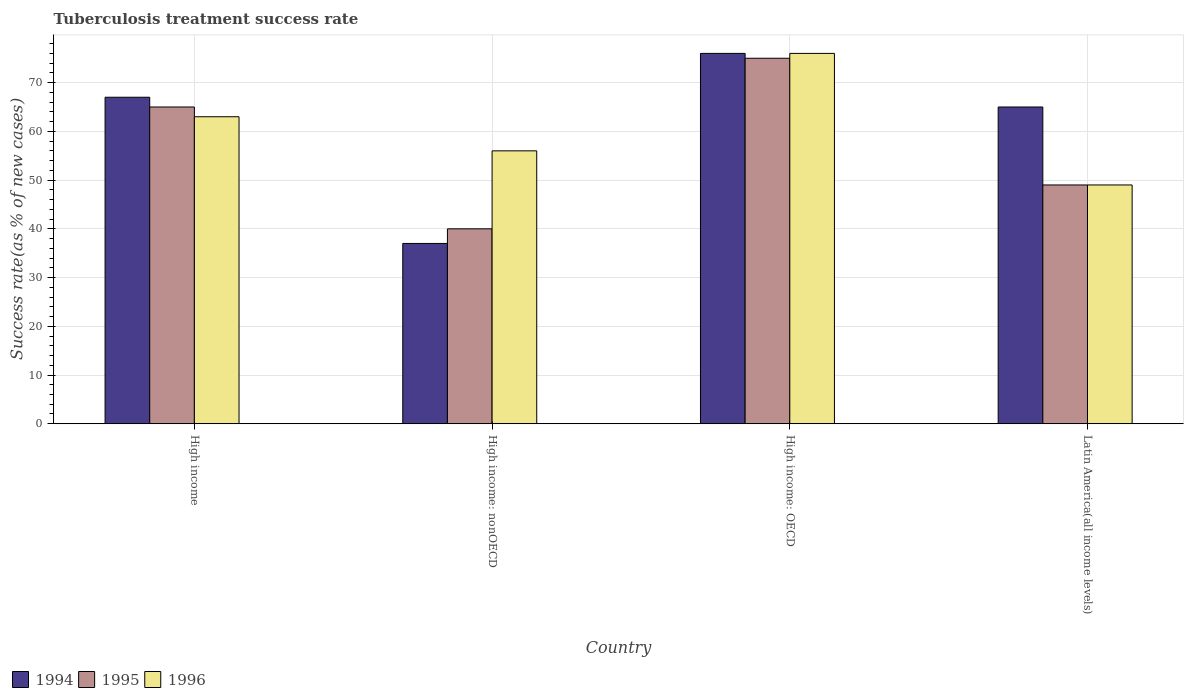How many different coloured bars are there?
Offer a terse response. 3. What is the label of the 4th group of bars from the left?
Keep it short and to the point. Latin America(all income levels). What is the tuberculosis treatment success rate in 1995 in High income?
Offer a very short reply. 65. In which country was the tuberculosis treatment success rate in 1994 maximum?
Offer a terse response. High income: OECD. In which country was the tuberculosis treatment success rate in 1994 minimum?
Offer a terse response. High income: nonOECD. What is the total tuberculosis treatment success rate in 1994 in the graph?
Make the answer very short. 245. What is the difference between the tuberculosis treatment success rate in 1994 in High income: nonOECD and that in Latin America(all income levels)?
Provide a succinct answer. -28. What is the difference between the tuberculosis treatment success rate in 1996 in High income: nonOECD and the tuberculosis treatment success rate in 1995 in Latin America(all income levels)?
Your answer should be very brief. 7. What is the difference between the tuberculosis treatment success rate of/in 1995 and tuberculosis treatment success rate of/in 1994 in High income: OECD?
Provide a short and direct response. -1. What is the ratio of the tuberculosis treatment success rate in 1994 in High income: OECD to that in High income: nonOECD?
Your answer should be compact. 2.05. Is the tuberculosis treatment success rate in 1994 in High income: nonOECD less than that in Latin America(all income levels)?
Make the answer very short. Yes. What is the difference between the highest and the second highest tuberculosis treatment success rate in 1996?
Your answer should be compact. -20. What is the difference between the highest and the lowest tuberculosis treatment success rate in 1994?
Offer a terse response. 39. Is the sum of the tuberculosis treatment success rate in 1994 in High income and High income: nonOECD greater than the maximum tuberculosis treatment success rate in 1996 across all countries?
Offer a terse response. Yes. Are all the bars in the graph horizontal?
Give a very brief answer. No. How many countries are there in the graph?
Keep it short and to the point. 4. Are the values on the major ticks of Y-axis written in scientific E-notation?
Offer a very short reply. No. Where does the legend appear in the graph?
Your response must be concise. Bottom left. What is the title of the graph?
Ensure brevity in your answer.  Tuberculosis treatment success rate. What is the label or title of the X-axis?
Keep it short and to the point. Country. What is the label or title of the Y-axis?
Ensure brevity in your answer.  Success rate(as % of new cases). What is the Success rate(as % of new cases) in 1994 in High income?
Keep it short and to the point. 67. What is the Success rate(as % of new cases) of 1996 in High income?
Keep it short and to the point. 63. What is the Success rate(as % of new cases) in 1994 in High income: nonOECD?
Your response must be concise. 37. What is the Success rate(as % of new cases) of 1994 in High income: OECD?
Make the answer very short. 76. What is the Success rate(as % of new cases) of 1996 in Latin America(all income levels)?
Your response must be concise. 49. Across all countries, what is the maximum Success rate(as % of new cases) in 1994?
Your answer should be compact. 76. Across all countries, what is the minimum Success rate(as % of new cases) in 1994?
Your answer should be very brief. 37. Across all countries, what is the minimum Success rate(as % of new cases) in 1996?
Ensure brevity in your answer.  49. What is the total Success rate(as % of new cases) in 1994 in the graph?
Keep it short and to the point. 245. What is the total Success rate(as % of new cases) of 1995 in the graph?
Make the answer very short. 229. What is the total Success rate(as % of new cases) in 1996 in the graph?
Offer a very short reply. 244. What is the difference between the Success rate(as % of new cases) of 1994 in High income and that in High income: nonOECD?
Provide a short and direct response. 30. What is the difference between the Success rate(as % of new cases) in 1995 in High income and that in High income: nonOECD?
Keep it short and to the point. 25. What is the difference between the Success rate(as % of new cases) of 1996 in High income and that in High income: nonOECD?
Your response must be concise. 7. What is the difference between the Success rate(as % of new cases) in 1994 in High income and that in High income: OECD?
Provide a short and direct response. -9. What is the difference between the Success rate(as % of new cases) of 1995 in High income and that in High income: OECD?
Your answer should be very brief. -10. What is the difference between the Success rate(as % of new cases) of 1996 in High income and that in High income: OECD?
Your response must be concise. -13. What is the difference between the Success rate(as % of new cases) in 1994 in High income and that in Latin America(all income levels)?
Offer a very short reply. 2. What is the difference between the Success rate(as % of new cases) of 1995 in High income and that in Latin America(all income levels)?
Your answer should be compact. 16. What is the difference between the Success rate(as % of new cases) in 1994 in High income: nonOECD and that in High income: OECD?
Offer a very short reply. -39. What is the difference between the Success rate(as % of new cases) of 1995 in High income: nonOECD and that in High income: OECD?
Your response must be concise. -35. What is the difference between the Success rate(as % of new cases) of 1996 in High income: nonOECD and that in High income: OECD?
Your answer should be compact. -20. What is the difference between the Success rate(as % of new cases) of 1995 in High income: nonOECD and that in Latin America(all income levels)?
Keep it short and to the point. -9. What is the difference between the Success rate(as % of new cases) of 1994 in High income: OECD and that in Latin America(all income levels)?
Your answer should be compact. 11. What is the difference between the Success rate(as % of new cases) of 1995 in High income: OECD and that in Latin America(all income levels)?
Keep it short and to the point. 26. What is the difference between the Success rate(as % of new cases) of 1994 in High income and the Success rate(as % of new cases) of 1995 in High income: nonOECD?
Ensure brevity in your answer.  27. What is the difference between the Success rate(as % of new cases) in 1994 in High income and the Success rate(as % of new cases) in 1996 in High income: OECD?
Your answer should be very brief. -9. What is the difference between the Success rate(as % of new cases) of 1994 in High income and the Success rate(as % of new cases) of 1995 in Latin America(all income levels)?
Give a very brief answer. 18. What is the difference between the Success rate(as % of new cases) of 1994 in High income: nonOECD and the Success rate(as % of new cases) of 1995 in High income: OECD?
Ensure brevity in your answer.  -38. What is the difference between the Success rate(as % of new cases) in 1994 in High income: nonOECD and the Success rate(as % of new cases) in 1996 in High income: OECD?
Ensure brevity in your answer.  -39. What is the difference between the Success rate(as % of new cases) of 1995 in High income: nonOECD and the Success rate(as % of new cases) of 1996 in High income: OECD?
Your answer should be very brief. -36. What is the difference between the Success rate(as % of new cases) of 1994 in High income: nonOECD and the Success rate(as % of new cases) of 1995 in Latin America(all income levels)?
Your answer should be very brief. -12. What is the difference between the Success rate(as % of new cases) in 1994 in High income: nonOECD and the Success rate(as % of new cases) in 1996 in Latin America(all income levels)?
Ensure brevity in your answer.  -12. What is the difference between the Success rate(as % of new cases) of 1995 in High income: nonOECD and the Success rate(as % of new cases) of 1996 in Latin America(all income levels)?
Make the answer very short. -9. What is the difference between the Success rate(as % of new cases) in 1994 in High income: OECD and the Success rate(as % of new cases) in 1995 in Latin America(all income levels)?
Your answer should be very brief. 27. What is the difference between the Success rate(as % of new cases) in 1994 in High income: OECD and the Success rate(as % of new cases) in 1996 in Latin America(all income levels)?
Your answer should be compact. 27. What is the difference between the Success rate(as % of new cases) of 1995 in High income: OECD and the Success rate(as % of new cases) of 1996 in Latin America(all income levels)?
Your answer should be very brief. 26. What is the average Success rate(as % of new cases) in 1994 per country?
Offer a terse response. 61.25. What is the average Success rate(as % of new cases) in 1995 per country?
Ensure brevity in your answer.  57.25. What is the average Success rate(as % of new cases) of 1996 per country?
Offer a very short reply. 61. What is the difference between the Success rate(as % of new cases) in 1994 and Success rate(as % of new cases) in 1995 in High income?
Provide a short and direct response. 2. What is the difference between the Success rate(as % of new cases) in 1994 and Success rate(as % of new cases) in 1996 in High income?
Make the answer very short. 4. What is the difference between the Success rate(as % of new cases) in 1995 and Success rate(as % of new cases) in 1996 in High income?
Your answer should be very brief. 2. What is the difference between the Success rate(as % of new cases) of 1994 and Success rate(as % of new cases) of 1995 in High income: nonOECD?
Give a very brief answer. -3. What is the difference between the Success rate(as % of new cases) in 1995 and Success rate(as % of new cases) in 1996 in High income: nonOECD?
Make the answer very short. -16. What is the difference between the Success rate(as % of new cases) in 1994 and Success rate(as % of new cases) in 1995 in High income: OECD?
Give a very brief answer. 1. What is the difference between the Success rate(as % of new cases) in 1995 and Success rate(as % of new cases) in 1996 in High income: OECD?
Offer a terse response. -1. What is the difference between the Success rate(as % of new cases) of 1994 and Success rate(as % of new cases) of 1996 in Latin America(all income levels)?
Offer a terse response. 16. What is the difference between the Success rate(as % of new cases) of 1995 and Success rate(as % of new cases) of 1996 in Latin America(all income levels)?
Provide a succinct answer. 0. What is the ratio of the Success rate(as % of new cases) in 1994 in High income to that in High income: nonOECD?
Provide a succinct answer. 1.81. What is the ratio of the Success rate(as % of new cases) in 1995 in High income to that in High income: nonOECD?
Ensure brevity in your answer.  1.62. What is the ratio of the Success rate(as % of new cases) in 1996 in High income to that in High income: nonOECD?
Keep it short and to the point. 1.12. What is the ratio of the Success rate(as % of new cases) in 1994 in High income to that in High income: OECD?
Keep it short and to the point. 0.88. What is the ratio of the Success rate(as % of new cases) in 1995 in High income to that in High income: OECD?
Make the answer very short. 0.87. What is the ratio of the Success rate(as % of new cases) in 1996 in High income to that in High income: OECD?
Give a very brief answer. 0.83. What is the ratio of the Success rate(as % of new cases) in 1994 in High income to that in Latin America(all income levels)?
Provide a succinct answer. 1.03. What is the ratio of the Success rate(as % of new cases) in 1995 in High income to that in Latin America(all income levels)?
Ensure brevity in your answer.  1.33. What is the ratio of the Success rate(as % of new cases) of 1996 in High income to that in Latin America(all income levels)?
Offer a very short reply. 1.29. What is the ratio of the Success rate(as % of new cases) in 1994 in High income: nonOECD to that in High income: OECD?
Make the answer very short. 0.49. What is the ratio of the Success rate(as % of new cases) of 1995 in High income: nonOECD to that in High income: OECD?
Provide a short and direct response. 0.53. What is the ratio of the Success rate(as % of new cases) in 1996 in High income: nonOECD to that in High income: OECD?
Ensure brevity in your answer.  0.74. What is the ratio of the Success rate(as % of new cases) of 1994 in High income: nonOECD to that in Latin America(all income levels)?
Make the answer very short. 0.57. What is the ratio of the Success rate(as % of new cases) in 1995 in High income: nonOECD to that in Latin America(all income levels)?
Give a very brief answer. 0.82. What is the ratio of the Success rate(as % of new cases) in 1996 in High income: nonOECD to that in Latin America(all income levels)?
Make the answer very short. 1.14. What is the ratio of the Success rate(as % of new cases) in 1994 in High income: OECD to that in Latin America(all income levels)?
Provide a short and direct response. 1.17. What is the ratio of the Success rate(as % of new cases) of 1995 in High income: OECD to that in Latin America(all income levels)?
Make the answer very short. 1.53. What is the ratio of the Success rate(as % of new cases) of 1996 in High income: OECD to that in Latin America(all income levels)?
Your response must be concise. 1.55. What is the difference between the highest and the second highest Success rate(as % of new cases) of 1995?
Give a very brief answer. 10. What is the difference between the highest and the second highest Success rate(as % of new cases) of 1996?
Provide a succinct answer. 13. What is the difference between the highest and the lowest Success rate(as % of new cases) of 1995?
Provide a succinct answer. 35. 